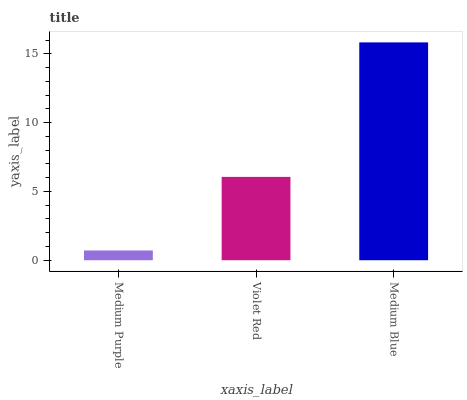Is Medium Purple the minimum?
Answer yes or no. Yes. Is Medium Blue the maximum?
Answer yes or no. Yes. Is Violet Red the minimum?
Answer yes or no. No. Is Violet Red the maximum?
Answer yes or no. No. Is Violet Red greater than Medium Purple?
Answer yes or no. Yes. Is Medium Purple less than Violet Red?
Answer yes or no. Yes. Is Medium Purple greater than Violet Red?
Answer yes or no. No. Is Violet Red less than Medium Purple?
Answer yes or no. No. Is Violet Red the high median?
Answer yes or no. Yes. Is Violet Red the low median?
Answer yes or no. Yes. Is Medium Blue the high median?
Answer yes or no. No. Is Medium Blue the low median?
Answer yes or no. No. 